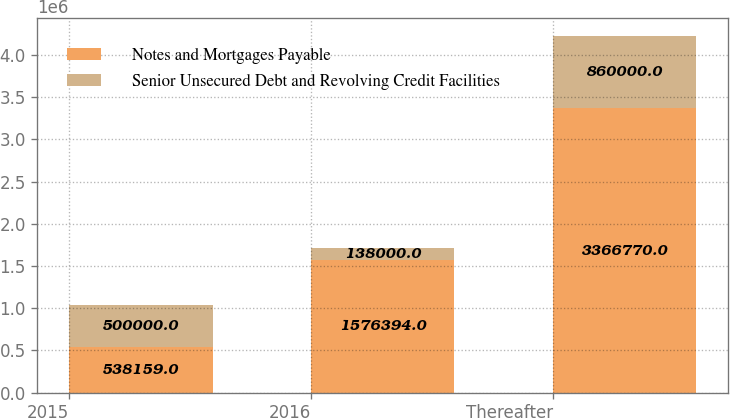Convert chart to OTSL. <chart><loc_0><loc_0><loc_500><loc_500><stacked_bar_chart><ecel><fcel>2015<fcel>2016<fcel>Thereafter<nl><fcel>Notes and Mortgages Payable<fcel>538159<fcel>1.57639e+06<fcel>3.36677e+06<nl><fcel>Senior Unsecured Debt and Revolving Credit Facilities<fcel>500000<fcel>138000<fcel>860000<nl></chart> 